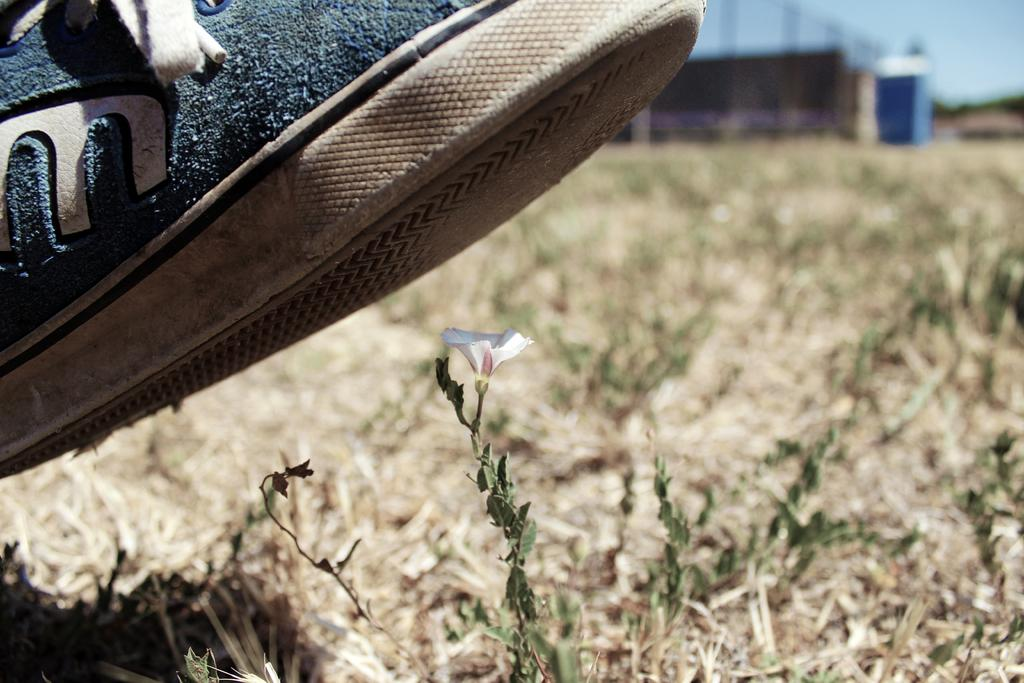What object can be seen in the image? There is a shoe in the image. What is located under the shoe? A flower is present under the shoe. What type of vegetation is visible in the image? There are plants in the image. How would you describe the background of the image? The background of the image is blurry. What type of cup can be seen in the image? There is no cup present in the image. How does the shoe contribute to the health of the plants in the image? The shoe does not contribute to the health of the plants in the image; it is simply placed on top of a flower. 